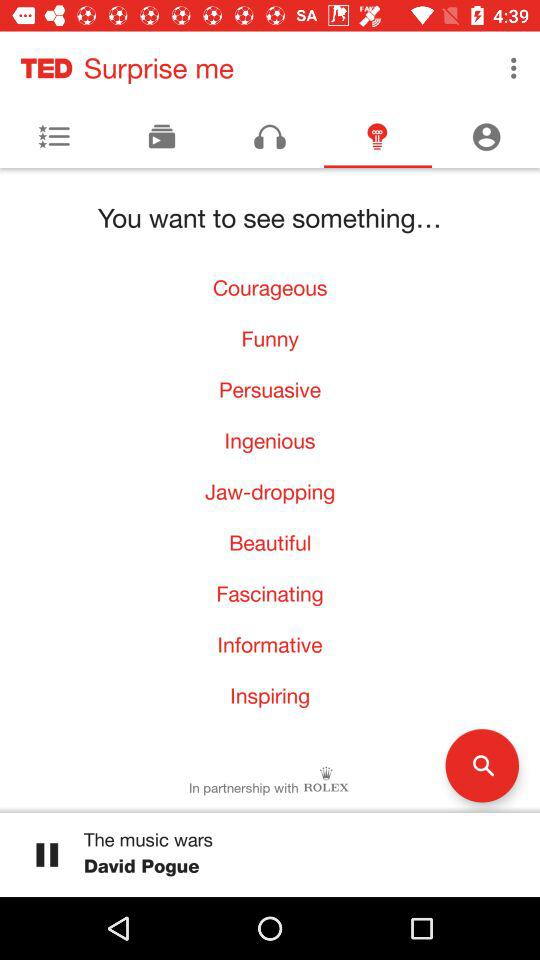Which TED talk is currently playing? The TED talk that is currently playing is "The music wars". 